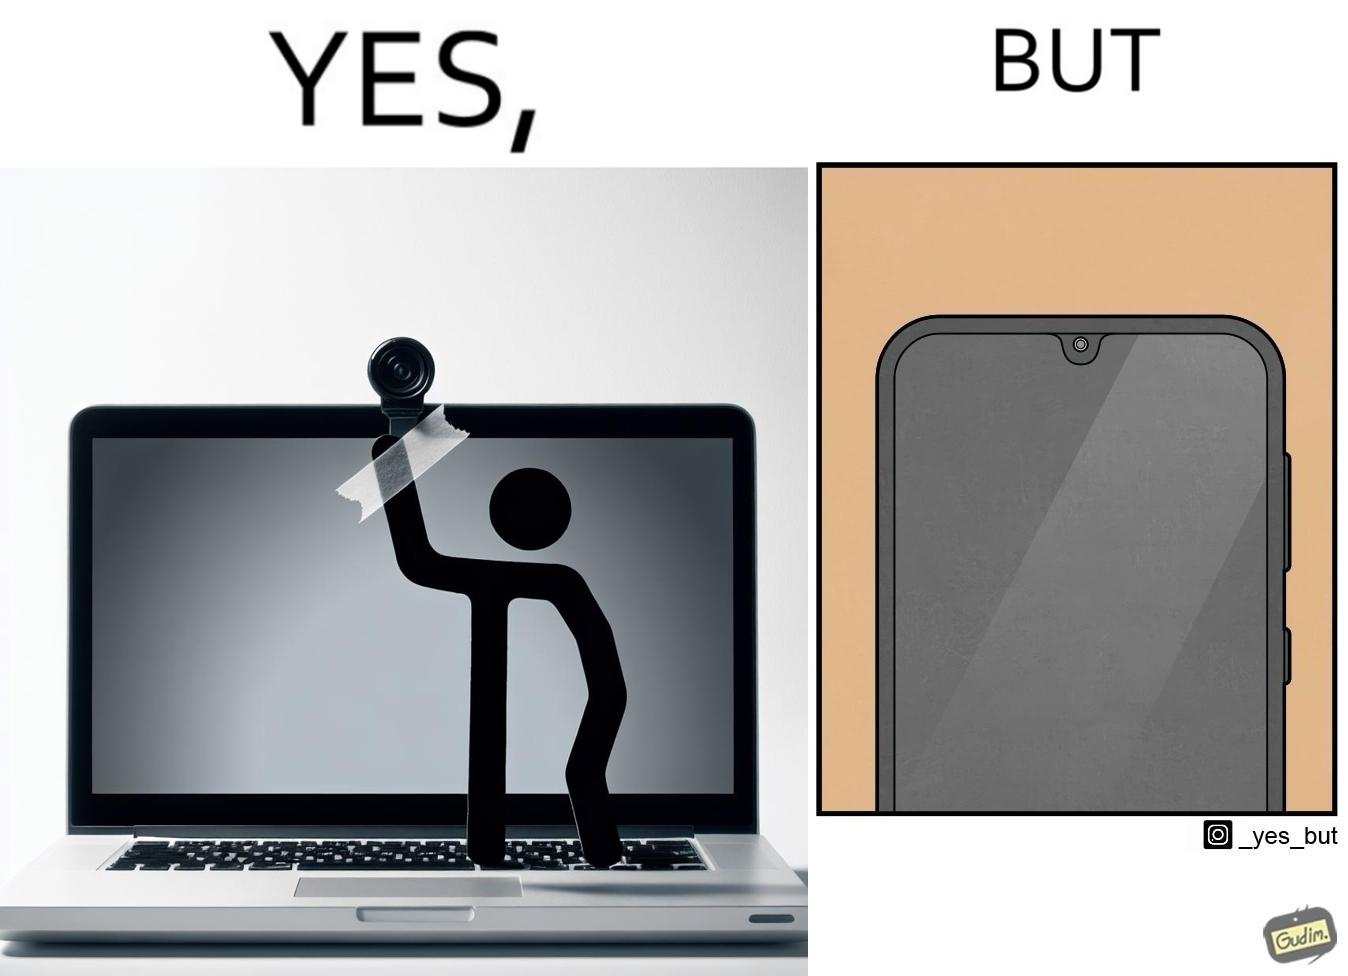Explain the humor or irony in this image. The image is ironic, because the person is seen as applying tape over laptop's camera over some privacy concerns but on the other hand he/she carries the phone without covering its camera 